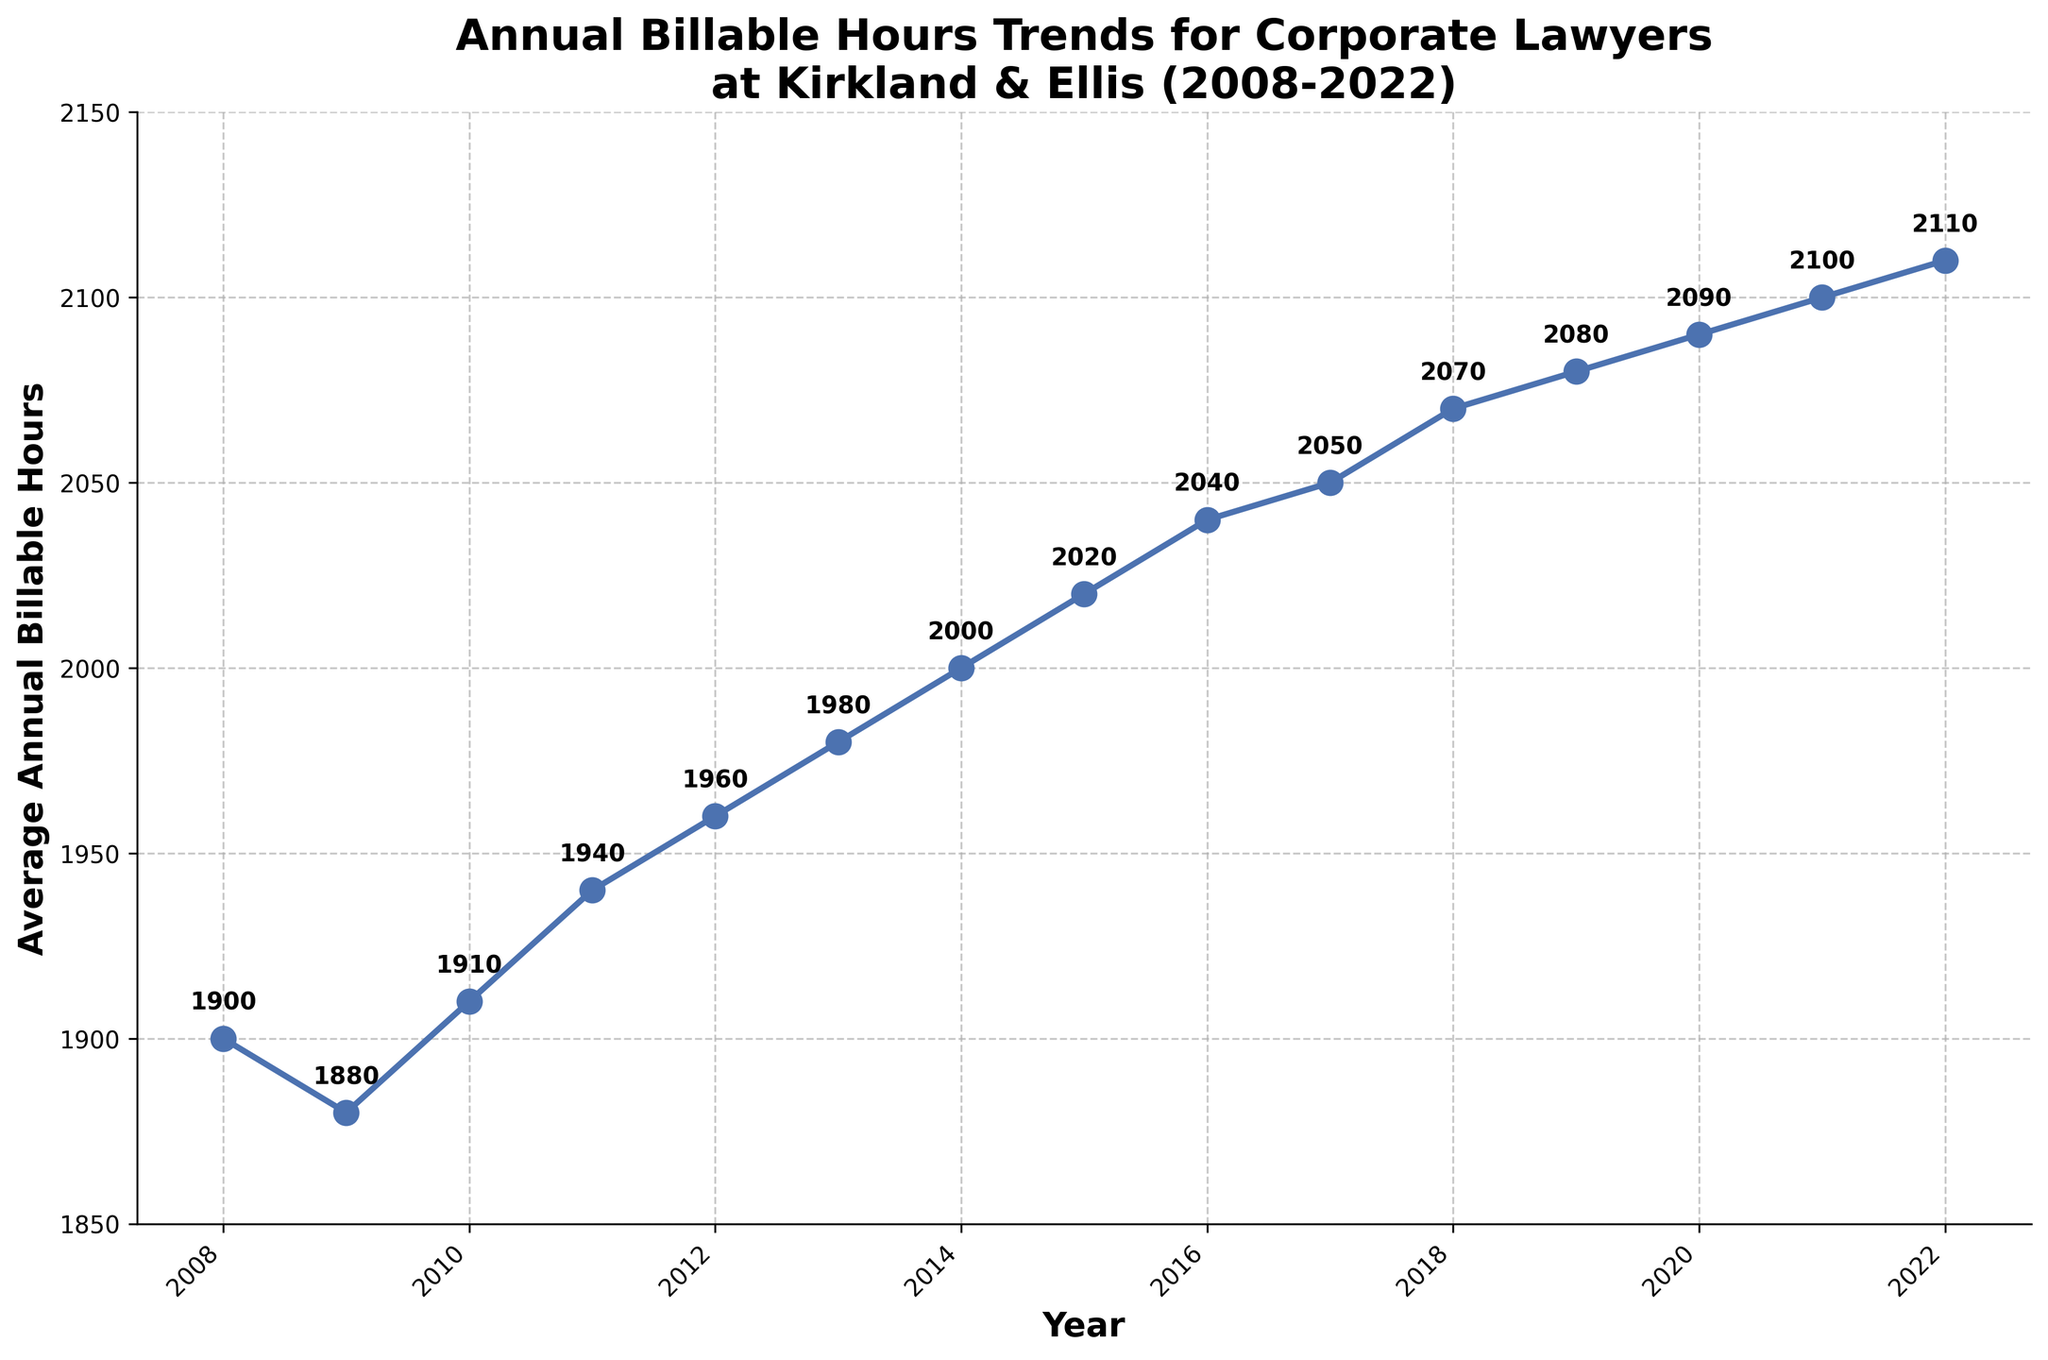What's the title of the figure? The title of the figure is usually placed at the top and describes the main subject of the plot. Here, it states the content and the time frame, which is given as "Annual Billable Hours Trends for Corporate Lawyers at Kirkland & Ellis (2008-2022)"
Answer: Annual Billable Hours Trends for Corporate Lawyers at Kirkland & Ellis (2008-2022) What does the x-axis represent in the plot? The x-axis is labeled 'Year' and has ticks marking each year from 2008 to 2022, indicating it represents the timeline over which the data was collected.
Answer: Year Which year had the lowest average annual billable hours? By looking for the shortest bar or the lowest plot point, we identify the year with the lowest average. In this graph, it's in 2009 where the plotted line reaches the lowest point with 1880 hours.
Answer: 2009 What are the average annual billable hours in 2022? You need to locate the point on the plot corresponding to the year 2022 and read off the value from the y-axis or the data label, which is 2110 hours.
Answer: 2110 hours What's the general trend of the average annual billable hours over the years shown? Examining the plot from left to right, we observe whether the line generally ascends, descends, or remains constant. Here, it consistently increases, indicating a steady upward trend in hours worked.
Answer: An upward trend By how many hours did the average annual billable hours increase from 2010 to 2020? Find the values for 2010 (1910 hours) and 2020 (2090 hours), then calculate the difference: 2090 - 1910 = 180.
Answer: 180 hours What is the average annual billable hours in 2011 and how does it compare to 2012? The average for 2011 is 1940 hours, and for 2012, it's 1960 hours, showing that 2012 had 20 more hours than 2011 (1960 - 1940 = 20).
Answer: 2011: 1940 hours, 2012: 1960 hours, 20 hours more Between which consecutive years is there the largest increase in average annual billable hours? We must compute the difference in hours between each pair of consecutive years and find the maximum increase. 2010 to 2011 is a 30 hours increase, similarly others should be calculated until the highest is found between 2014 to 2015 with an increase of 20 hours, hence no other consecutive years have a larger incremental value compared to that figure.
Answer: Between 2019 and 2020, with 10 hours What was the average increase per year in billable hours from 2008 to 2022? First, note the values for 2008 (1900 hours) and 2022 (2110 hours), calculate the total increase (2110 - 1900 = 210), then divide by the number of years (2022 - 2008 = 15): 210 / 15 = 14.
Answer: 14 hours per year 